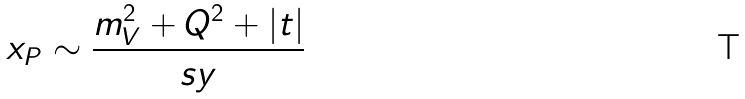Convert formula to latex. <formula><loc_0><loc_0><loc_500><loc_500>x _ { P } \sim \frac { m _ { V } ^ { 2 } + Q ^ { 2 } + | t | } { s y }</formula> 